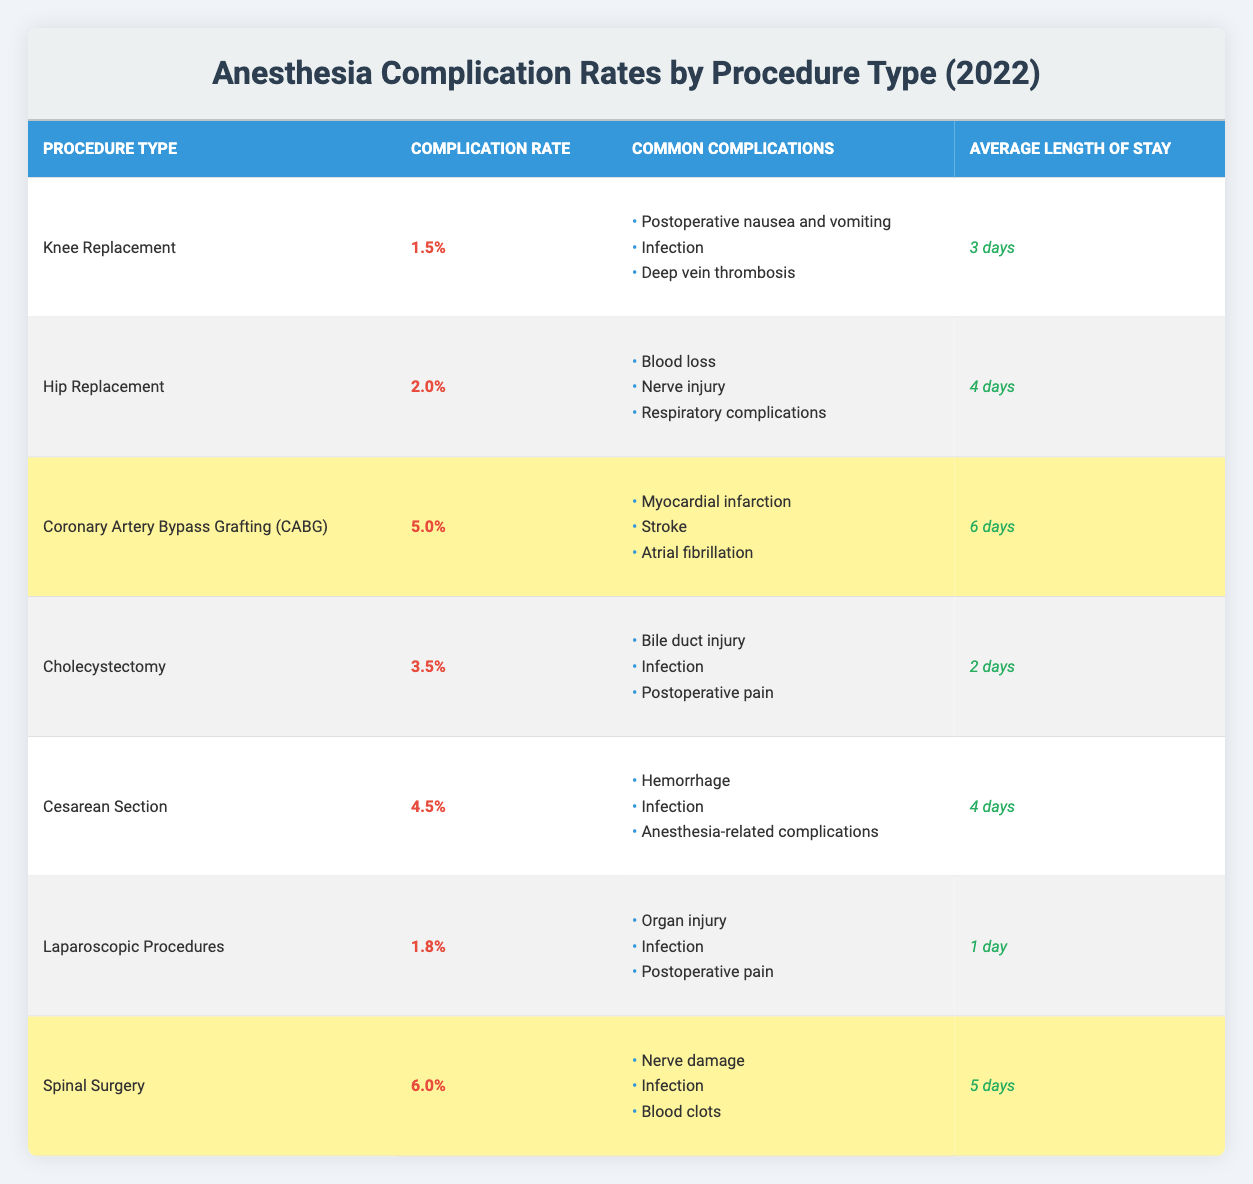What is the complication rate for Hip Replacement? The table lists the complication rate for Hip Replacement as 2.0%.
Answer: 2.0% Which procedure has the highest complication rate? Spinal Surgery has the highest complication rate at 6.0% as indicated in the table.
Answer: Spinal Surgery How many common complications are listed for Coronary Artery Bypass Grafting (CABG)? The table shows three common complications associated with CABG: myocardial infarction, stroke, and atrial fibrillation.
Answer: 3 What is the difference in complication rates between Cesarean Section and Cholecystectomy? Cesarean Section has a complication rate of 4.5% and Cholecystectomy has a rate of 3.5%. The difference is 4.5% - 3.5% = 1.0%.
Answer: 1.0% Which procedure type has the shortest average length of stay? The table states that Laparoscopic Procedures have the shortest average length of stay at 1 day, compared to all other procedures listed.
Answer: Laparoscopic Procedures Are postoperative nausea and vomiting common complications for Cesarean Section? The table indicates that postoperative nausea and vomiting is not a common complication of Cesarean Section, as it lists hemorrhage, infection, and anesthesia-related complications instead.
Answer: No What is the average complication rate for all the procedures listed? To find the average, we sum the complication rates: (1.5% + 2.0% + 5.0% + 3.5% + 4.5% + 1.8% + 6.0%) = 24.3%. There are 7 procedures, so the average is 24.3% / 7 ≈ 3.47%.
Answer: 3.47% Which procedure has the longest average length of stay, and what is that duration? The procedure with the longest average length of stay is Coronary Artery Bypass Grafting (CABG) at 6 days, as shown in the table.
Answer: CABG, 6 days If you had to choose a procedure with a complication rate above 4%, which options would you have? The table identifies three procedures with complication rates above 4%: Coronary Artery Bypass Grafting (5.0%), Cesarean Section (4.5%), and Spinal Surgery (6.0%).
Answer: CABG, Cesarean Section, Spinal Surgery What percentage of complication rates is associated with Knee Replacement? The complication rate for Knee Replacement is stated in the table as 1.5%.
Answer: 1.5% 